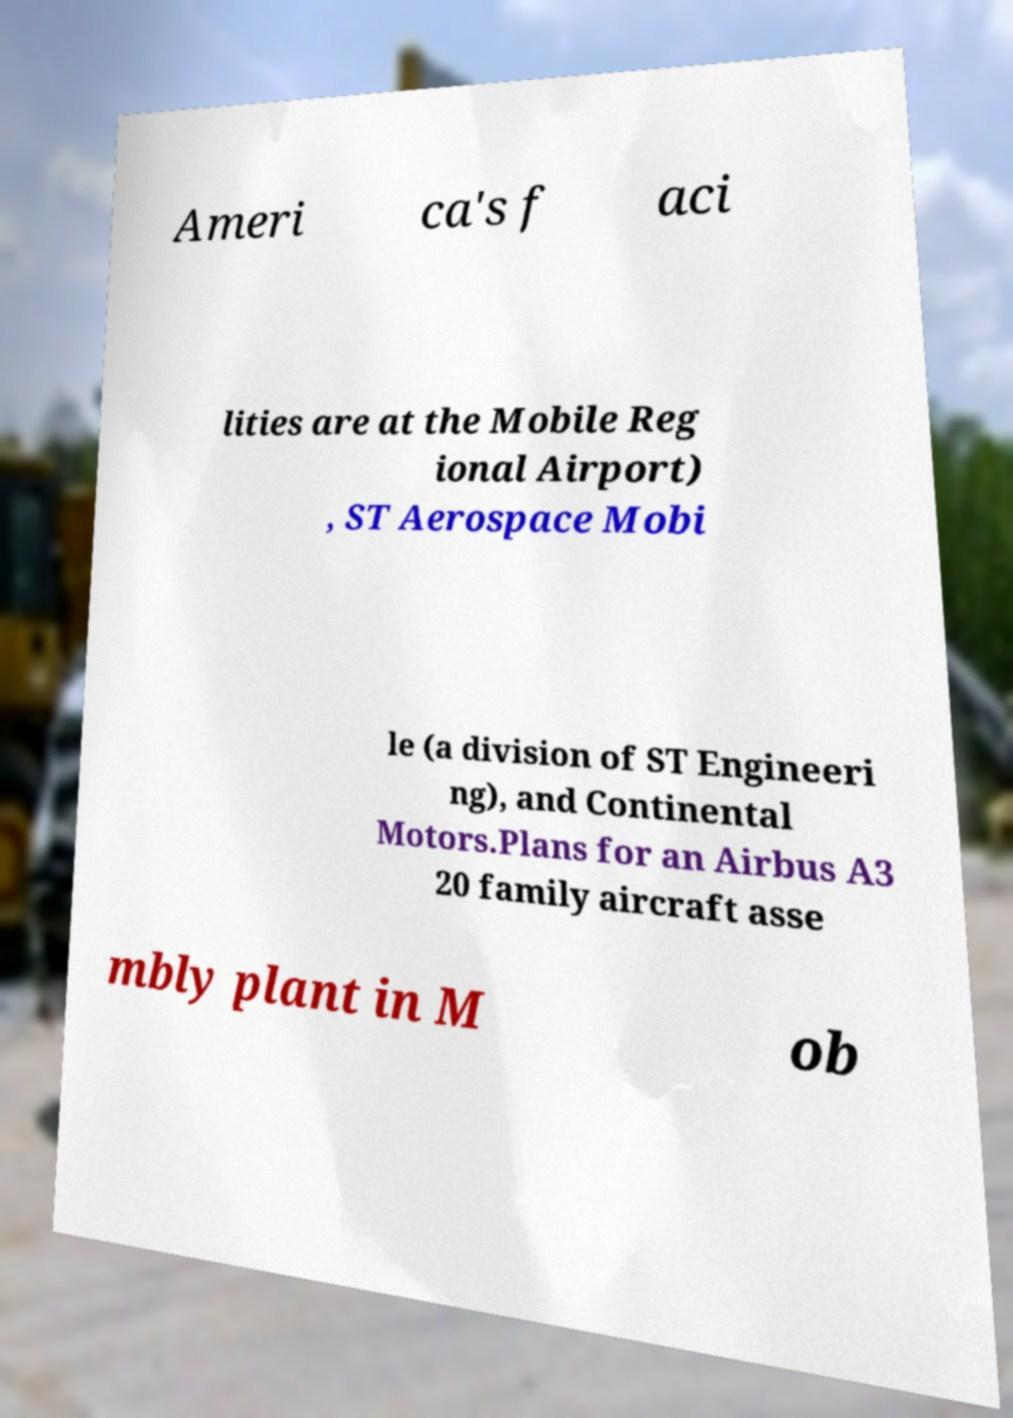I need the written content from this picture converted into text. Can you do that? Ameri ca's f aci lities are at the Mobile Reg ional Airport) , ST Aerospace Mobi le (a division of ST Engineeri ng), and Continental Motors.Plans for an Airbus A3 20 family aircraft asse mbly plant in M ob 